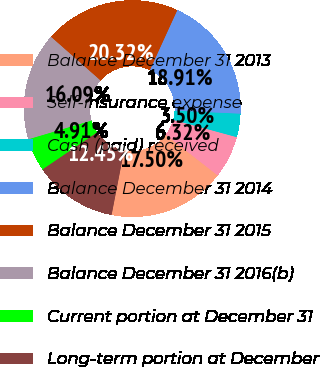Convert chart. <chart><loc_0><loc_0><loc_500><loc_500><pie_chart><fcel>Balance December 31 2013<fcel>Self-insurance expense<fcel>Cash (paid) received<fcel>Balance December 31 2014<fcel>Balance December 31 2015<fcel>Balance December 31 2016(b)<fcel>Current portion at December 31<fcel>Long-term portion at December<nl><fcel>17.5%<fcel>6.32%<fcel>3.5%<fcel>18.91%<fcel>20.32%<fcel>16.09%<fcel>4.91%<fcel>12.45%<nl></chart> 